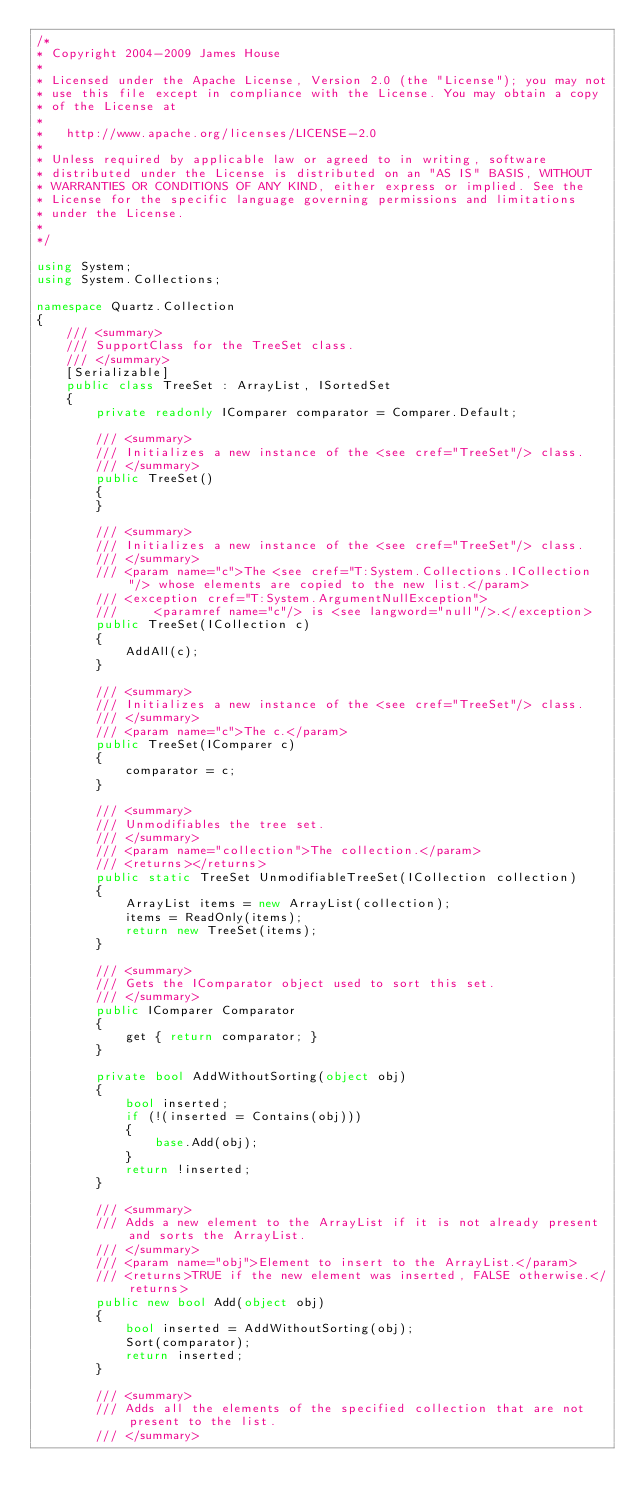Convert code to text. <code><loc_0><loc_0><loc_500><loc_500><_C#_>/* 
* Copyright 2004-2009 James House 
* 
* Licensed under the Apache License, Version 2.0 (the "License"); you may not 
* use this file except in compliance with the License. You may obtain a copy 
* of the License at 
* 
*   http://www.apache.org/licenses/LICENSE-2.0 
*   
* Unless required by applicable law or agreed to in writing, software 
* distributed under the License is distributed on an "AS IS" BASIS, WITHOUT 
* WARRANTIES OR CONDITIONS OF ANY KIND, either express or implied. See the 
* License for the specific language governing permissions and limitations 
* under the License.
* 
*/

using System;
using System.Collections;

namespace Quartz.Collection
{
    /// <summary>
    /// SupportClass for the TreeSet class.
    /// </summary>
    [Serializable]
    public class TreeSet : ArrayList, ISortedSet
    {
        private readonly IComparer comparator = Comparer.Default;

        /// <summary>
        /// Initializes a new instance of the <see cref="TreeSet"/> class.
        /// </summary>
        public TreeSet()
        {
        }

        /// <summary>
        /// Initializes a new instance of the <see cref="TreeSet"/> class.
        /// </summary>
        /// <param name="c">The <see cref="T:System.Collections.ICollection"/> whose elements are copied to the new list.</param>
        /// <exception cref="T:System.ArgumentNullException">
        /// 	<paramref name="c"/> is <see langword="null"/>.</exception>
        public TreeSet(ICollection c)
        {
            AddAll(c);
        }

        /// <summary>
        /// Initializes a new instance of the <see cref="TreeSet"/> class.
        /// </summary>
        /// <param name="c">The c.</param>
        public TreeSet(IComparer c)
        {
            comparator = c;
        }

        /// <summary>
        /// Unmodifiables the tree set.
        /// </summary>
        /// <param name="collection">The collection.</param>
        /// <returns></returns>
        public static TreeSet UnmodifiableTreeSet(ICollection collection)
        {
            ArrayList items = new ArrayList(collection);
            items = ReadOnly(items);
            return new TreeSet(items);
        }

        /// <summary>
        /// Gets the IComparator object used to sort this set.
        /// </summary>
        public IComparer Comparator
        {
            get { return comparator; }
        }

        private bool AddWithoutSorting(object obj)
        {
            bool inserted;
            if (!(inserted = Contains(obj)))
            {
                base.Add(obj);
            }
            return !inserted;
        }

        /// <summary>
        /// Adds a new element to the ArrayList if it is not already present and sorts the ArrayList.
        /// </summary>
        /// <param name="obj">Element to insert to the ArrayList.</param>
        /// <returns>TRUE if the new element was inserted, FALSE otherwise.</returns>
        public new bool Add(object obj)
        {
            bool inserted = AddWithoutSorting(obj);
            Sort(comparator);
            return inserted;
        }

        /// <summary>
        /// Adds all the elements of the specified collection that are not present to the list.
        /// </summary>		</code> 